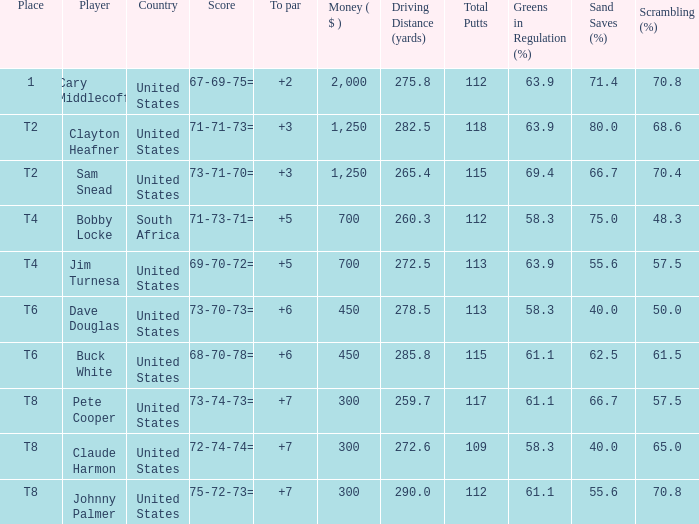What Country is Player Sam Snead with a To par of less than 5 from? United States. 